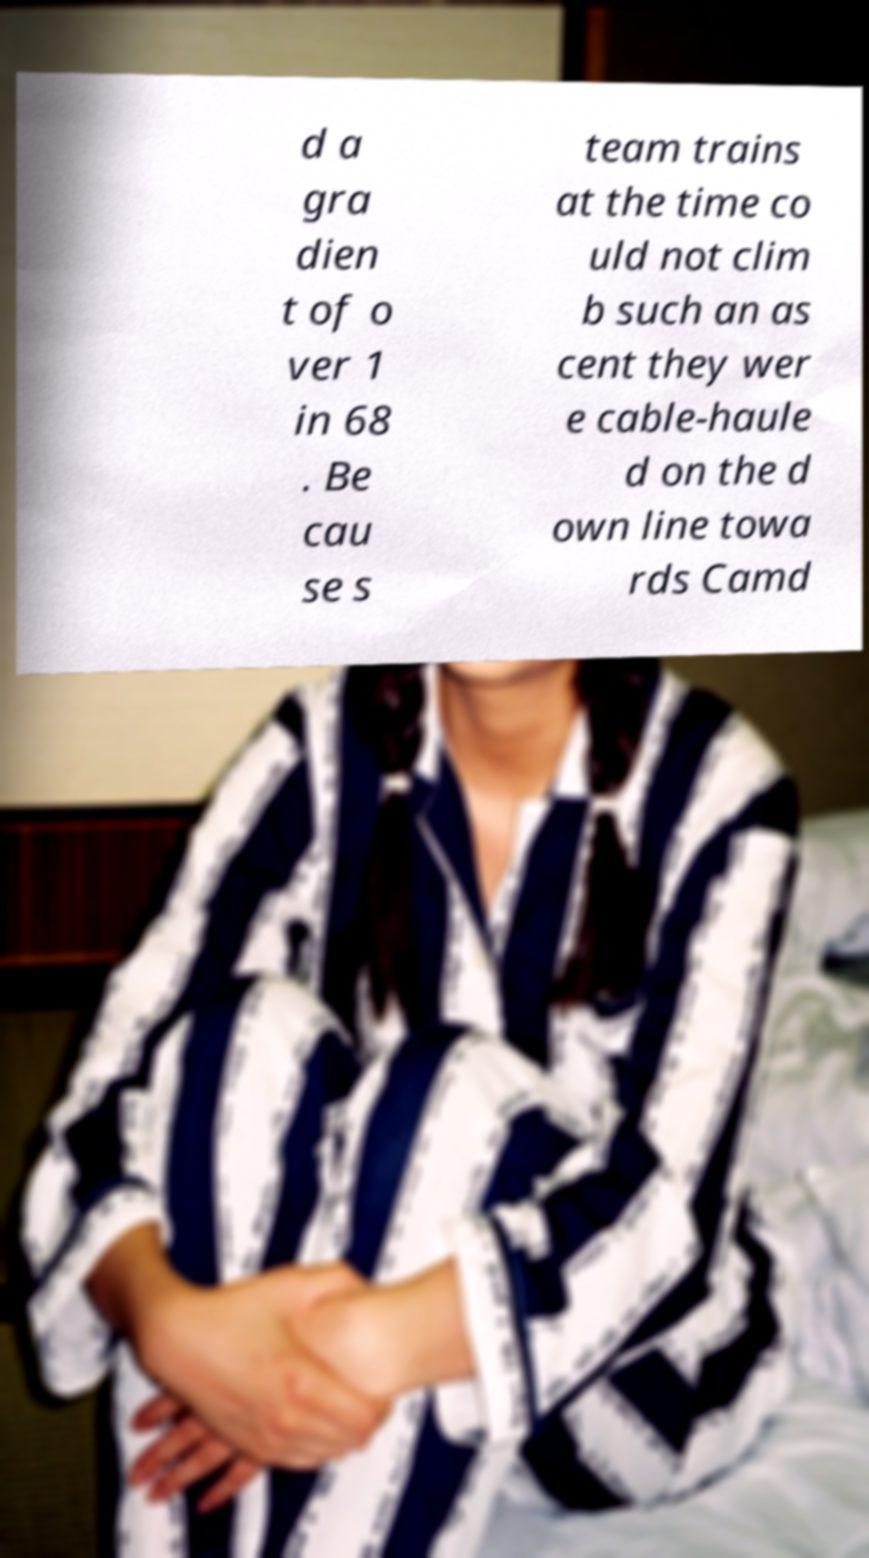For documentation purposes, I need the text within this image transcribed. Could you provide that? d a gra dien t of o ver 1 in 68 . Be cau se s team trains at the time co uld not clim b such an as cent they wer e cable-haule d on the d own line towa rds Camd 